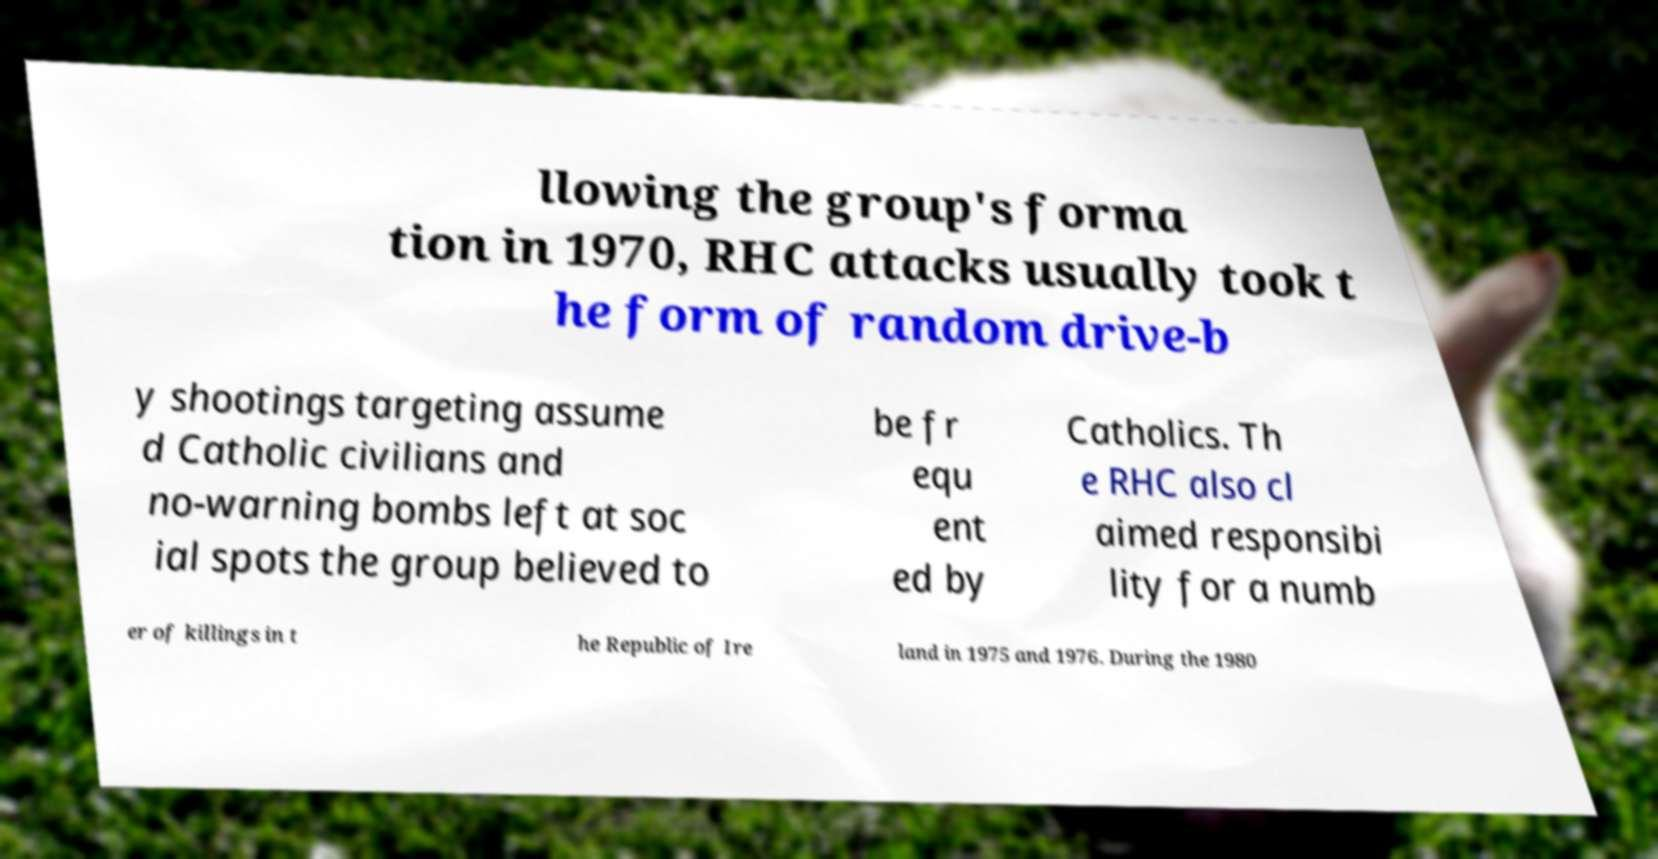Can you read and provide the text displayed in the image?This photo seems to have some interesting text. Can you extract and type it out for me? llowing the group's forma tion in 1970, RHC attacks usually took t he form of random drive-b y shootings targeting assume d Catholic civilians and no-warning bombs left at soc ial spots the group believed to be fr equ ent ed by Catholics. Th e RHC also cl aimed responsibi lity for a numb er of killings in t he Republic of Ire land in 1975 and 1976. During the 1980 